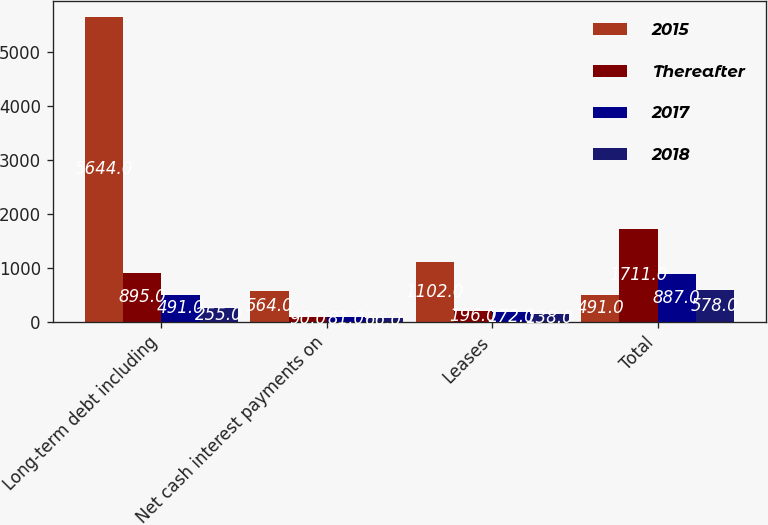Convert chart to OTSL. <chart><loc_0><loc_0><loc_500><loc_500><stacked_bar_chart><ecel><fcel>Long-term debt including<fcel>Net cash interest payments on<fcel>Leases<fcel>Total<nl><fcel>2015<fcel>5644<fcel>564<fcel>1102<fcel>491<nl><fcel>Thereafter<fcel>895<fcel>90<fcel>196<fcel>1711<nl><fcel>2017<fcel>491<fcel>81<fcel>172<fcel>887<nl><fcel>2018<fcel>255<fcel>66<fcel>138<fcel>578<nl></chart> 